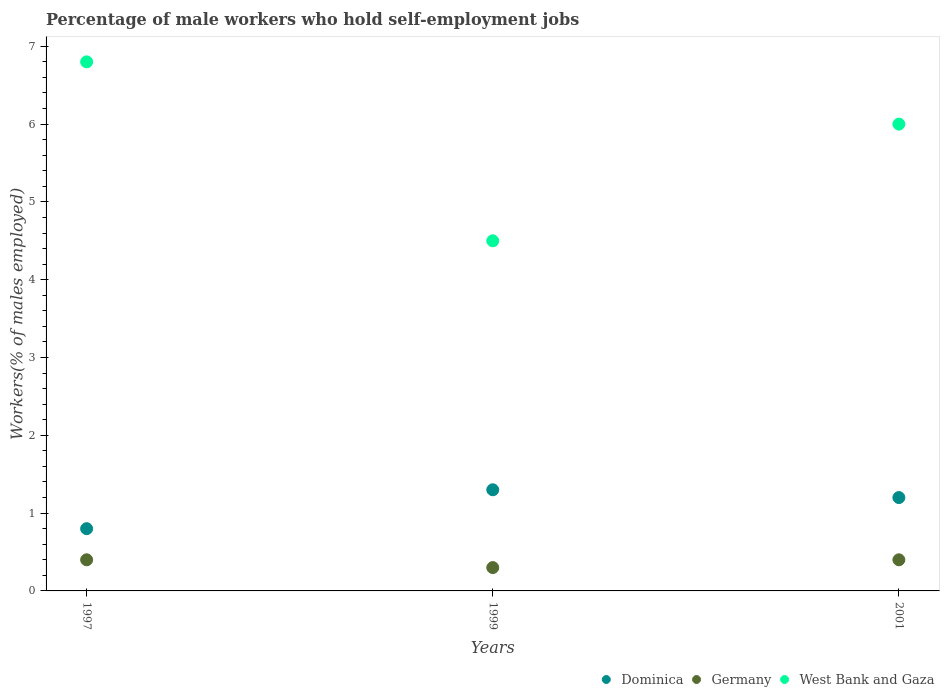What is the percentage of self-employed male workers in Germany in 2001?
Offer a very short reply. 0.4. Across all years, what is the maximum percentage of self-employed male workers in Germany?
Offer a very short reply. 0.4. Across all years, what is the minimum percentage of self-employed male workers in West Bank and Gaza?
Offer a terse response. 4.5. In which year was the percentage of self-employed male workers in West Bank and Gaza minimum?
Keep it short and to the point. 1999. What is the total percentage of self-employed male workers in Germany in the graph?
Keep it short and to the point. 1.1. What is the difference between the percentage of self-employed male workers in West Bank and Gaza in 1999 and that in 2001?
Offer a terse response. -1.5. What is the difference between the percentage of self-employed male workers in West Bank and Gaza in 1999 and the percentage of self-employed male workers in Germany in 2001?
Provide a short and direct response. 4.1. What is the average percentage of self-employed male workers in Dominica per year?
Offer a terse response. 1.1. In the year 1997, what is the difference between the percentage of self-employed male workers in Germany and percentage of self-employed male workers in Dominica?
Your answer should be compact. -0.4. In how many years, is the percentage of self-employed male workers in Germany greater than 1.6 %?
Keep it short and to the point. 0. Is the percentage of self-employed male workers in Dominica in 1997 less than that in 1999?
Offer a very short reply. Yes. What is the difference between the highest and the second highest percentage of self-employed male workers in Dominica?
Ensure brevity in your answer.  0.1. What is the difference between the highest and the lowest percentage of self-employed male workers in Germany?
Provide a succinct answer. 0.1. Is the sum of the percentage of self-employed male workers in Germany in 1997 and 1999 greater than the maximum percentage of self-employed male workers in Dominica across all years?
Offer a terse response. No. Is it the case that in every year, the sum of the percentage of self-employed male workers in Dominica and percentage of self-employed male workers in Germany  is greater than the percentage of self-employed male workers in West Bank and Gaza?
Offer a terse response. No. Does the percentage of self-employed male workers in West Bank and Gaza monotonically increase over the years?
Your response must be concise. No. Is the percentage of self-employed male workers in Dominica strictly less than the percentage of self-employed male workers in West Bank and Gaza over the years?
Your answer should be compact. Yes. How many dotlines are there?
Offer a very short reply. 3. Are the values on the major ticks of Y-axis written in scientific E-notation?
Your response must be concise. No. Does the graph contain any zero values?
Provide a short and direct response. No. Does the graph contain grids?
Make the answer very short. No. Where does the legend appear in the graph?
Provide a succinct answer. Bottom right. How many legend labels are there?
Give a very brief answer. 3. How are the legend labels stacked?
Make the answer very short. Horizontal. What is the title of the graph?
Provide a short and direct response. Percentage of male workers who hold self-employment jobs. Does "Mexico" appear as one of the legend labels in the graph?
Provide a short and direct response. No. What is the label or title of the X-axis?
Keep it short and to the point. Years. What is the label or title of the Y-axis?
Your answer should be compact. Workers(% of males employed). What is the Workers(% of males employed) in Dominica in 1997?
Offer a very short reply. 0.8. What is the Workers(% of males employed) in Germany in 1997?
Give a very brief answer. 0.4. What is the Workers(% of males employed) in West Bank and Gaza in 1997?
Make the answer very short. 6.8. What is the Workers(% of males employed) of Dominica in 1999?
Your response must be concise. 1.3. What is the Workers(% of males employed) in Germany in 1999?
Give a very brief answer. 0.3. What is the Workers(% of males employed) in West Bank and Gaza in 1999?
Offer a terse response. 4.5. What is the Workers(% of males employed) of Dominica in 2001?
Your response must be concise. 1.2. What is the Workers(% of males employed) of Germany in 2001?
Your response must be concise. 0.4. What is the Workers(% of males employed) of West Bank and Gaza in 2001?
Keep it short and to the point. 6. Across all years, what is the maximum Workers(% of males employed) of Dominica?
Make the answer very short. 1.3. Across all years, what is the maximum Workers(% of males employed) of Germany?
Give a very brief answer. 0.4. Across all years, what is the maximum Workers(% of males employed) in West Bank and Gaza?
Provide a succinct answer. 6.8. Across all years, what is the minimum Workers(% of males employed) in Dominica?
Ensure brevity in your answer.  0.8. Across all years, what is the minimum Workers(% of males employed) in Germany?
Make the answer very short. 0.3. Across all years, what is the minimum Workers(% of males employed) in West Bank and Gaza?
Provide a succinct answer. 4.5. What is the total Workers(% of males employed) of Dominica in the graph?
Provide a succinct answer. 3.3. What is the total Workers(% of males employed) in Germany in the graph?
Provide a succinct answer. 1.1. What is the total Workers(% of males employed) of West Bank and Gaza in the graph?
Ensure brevity in your answer.  17.3. What is the difference between the Workers(% of males employed) of Dominica in 1997 and that in 1999?
Offer a terse response. -0.5. What is the difference between the Workers(% of males employed) in Germany in 1997 and that in 1999?
Ensure brevity in your answer.  0.1. What is the difference between the Workers(% of males employed) in Germany in 1997 and that in 2001?
Your answer should be very brief. 0. What is the difference between the Workers(% of males employed) of West Bank and Gaza in 1997 and that in 2001?
Offer a terse response. 0.8. What is the difference between the Workers(% of males employed) in Dominica in 1999 and that in 2001?
Make the answer very short. 0.1. What is the difference between the Workers(% of males employed) of West Bank and Gaza in 1999 and that in 2001?
Keep it short and to the point. -1.5. What is the difference between the Workers(% of males employed) in Dominica in 1997 and the Workers(% of males employed) in Germany in 1999?
Your response must be concise. 0.5. What is the difference between the Workers(% of males employed) of Dominica in 1997 and the Workers(% of males employed) of West Bank and Gaza in 1999?
Your answer should be compact. -3.7. What is the difference between the Workers(% of males employed) in Dominica in 1997 and the Workers(% of males employed) in West Bank and Gaza in 2001?
Your answer should be compact. -5.2. What is the difference between the Workers(% of males employed) in Germany in 1997 and the Workers(% of males employed) in West Bank and Gaza in 2001?
Offer a terse response. -5.6. What is the difference between the Workers(% of males employed) of Dominica in 1999 and the Workers(% of males employed) of West Bank and Gaza in 2001?
Provide a succinct answer. -4.7. What is the average Workers(% of males employed) in Germany per year?
Keep it short and to the point. 0.37. What is the average Workers(% of males employed) of West Bank and Gaza per year?
Offer a very short reply. 5.77. In the year 1997, what is the difference between the Workers(% of males employed) of Dominica and Workers(% of males employed) of Germany?
Your answer should be very brief. 0.4. In the year 1997, what is the difference between the Workers(% of males employed) in Dominica and Workers(% of males employed) in West Bank and Gaza?
Offer a terse response. -6. In the year 1997, what is the difference between the Workers(% of males employed) in Germany and Workers(% of males employed) in West Bank and Gaza?
Provide a succinct answer. -6.4. In the year 1999, what is the difference between the Workers(% of males employed) of Dominica and Workers(% of males employed) of West Bank and Gaza?
Ensure brevity in your answer.  -3.2. What is the ratio of the Workers(% of males employed) in Dominica in 1997 to that in 1999?
Provide a short and direct response. 0.62. What is the ratio of the Workers(% of males employed) in West Bank and Gaza in 1997 to that in 1999?
Ensure brevity in your answer.  1.51. What is the ratio of the Workers(% of males employed) of Germany in 1997 to that in 2001?
Offer a very short reply. 1. What is the ratio of the Workers(% of males employed) in West Bank and Gaza in 1997 to that in 2001?
Keep it short and to the point. 1.13. What is the ratio of the Workers(% of males employed) of Dominica in 1999 to that in 2001?
Give a very brief answer. 1.08. What is the difference between the highest and the second highest Workers(% of males employed) of West Bank and Gaza?
Ensure brevity in your answer.  0.8. What is the difference between the highest and the lowest Workers(% of males employed) in Germany?
Keep it short and to the point. 0.1. What is the difference between the highest and the lowest Workers(% of males employed) of West Bank and Gaza?
Provide a short and direct response. 2.3. 